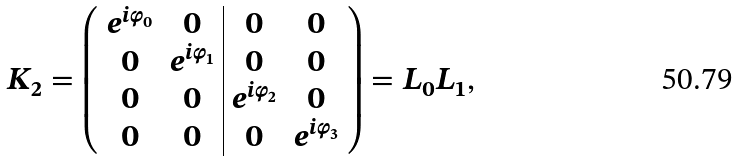Convert formula to latex. <formula><loc_0><loc_0><loc_500><loc_500>K _ { 2 } = \left ( \begin{array} { c c | c c } e ^ { i \varphi _ { 0 } } & 0 & 0 & 0 \\ 0 & e ^ { i \varphi _ { 1 } } & 0 & 0 \\ 0 & 0 & e ^ { i \varphi _ { 2 } } & 0 \\ 0 & 0 & 0 & e ^ { i \varphi _ { 3 } } \\ \end{array} \right ) = L _ { 0 } L _ { 1 } ,</formula> 